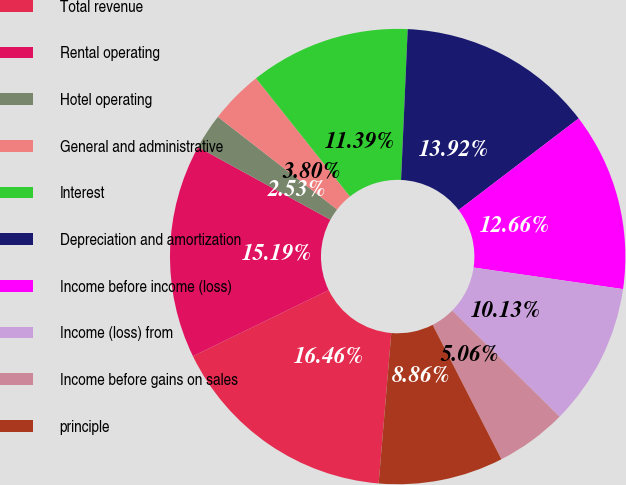Convert chart. <chart><loc_0><loc_0><loc_500><loc_500><pie_chart><fcel>Total revenue<fcel>Rental operating<fcel>Hotel operating<fcel>General and administrative<fcel>Interest<fcel>Depreciation and amortization<fcel>Income before income (loss)<fcel>Income (loss) from<fcel>Income before gains on sales<fcel>principle<nl><fcel>16.46%<fcel>15.19%<fcel>2.53%<fcel>3.8%<fcel>11.39%<fcel>13.92%<fcel>12.66%<fcel>10.13%<fcel>5.06%<fcel>8.86%<nl></chart> 